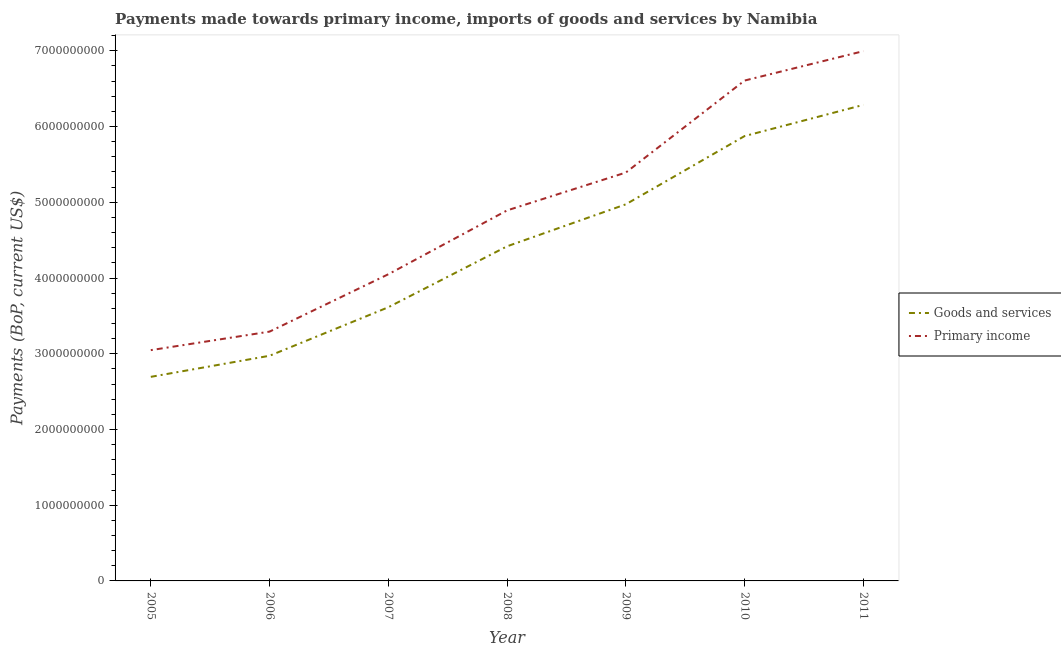How many different coloured lines are there?
Make the answer very short. 2. What is the payments made towards goods and services in 2006?
Give a very brief answer. 2.97e+09. Across all years, what is the maximum payments made towards primary income?
Provide a short and direct response. 7.00e+09. Across all years, what is the minimum payments made towards goods and services?
Make the answer very short. 2.69e+09. What is the total payments made towards primary income in the graph?
Provide a succinct answer. 3.43e+1. What is the difference between the payments made towards primary income in 2005 and that in 2010?
Your answer should be very brief. -3.56e+09. What is the difference between the payments made towards primary income in 2009 and the payments made towards goods and services in 2008?
Offer a terse response. 9.74e+08. What is the average payments made towards primary income per year?
Your answer should be very brief. 4.90e+09. In the year 2011, what is the difference between the payments made towards primary income and payments made towards goods and services?
Keep it short and to the point. 7.10e+08. What is the ratio of the payments made towards goods and services in 2007 to that in 2008?
Your answer should be very brief. 0.82. Is the payments made towards primary income in 2007 less than that in 2011?
Offer a terse response. Yes. Is the difference between the payments made towards goods and services in 2008 and 2009 greater than the difference between the payments made towards primary income in 2008 and 2009?
Your answer should be very brief. No. What is the difference between the highest and the second highest payments made towards primary income?
Offer a very short reply. 3.88e+08. What is the difference between the highest and the lowest payments made towards primary income?
Offer a terse response. 3.95e+09. Does the payments made towards primary income monotonically increase over the years?
Give a very brief answer. Yes. Is the payments made towards goods and services strictly less than the payments made towards primary income over the years?
Provide a succinct answer. Yes. How many years are there in the graph?
Your response must be concise. 7. What is the difference between two consecutive major ticks on the Y-axis?
Offer a very short reply. 1.00e+09. Are the values on the major ticks of Y-axis written in scientific E-notation?
Your answer should be very brief. No. Where does the legend appear in the graph?
Ensure brevity in your answer.  Center right. How are the legend labels stacked?
Your response must be concise. Vertical. What is the title of the graph?
Keep it short and to the point. Payments made towards primary income, imports of goods and services by Namibia. Does "IMF nonconcessional" appear as one of the legend labels in the graph?
Ensure brevity in your answer.  No. What is the label or title of the X-axis?
Offer a very short reply. Year. What is the label or title of the Y-axis?
Your answer should be compact. Payments (BoP, current US$). What is the Payments (BoP, current US$) in Goods and services in 2005?
Your response must be concise. 2.69e+09. What is the Payments (BoP, current US$) of Primary income in 2005?
Offer a terse response. 3.05e+09. What is the Payments (BoP, current US$) in Goods and services in 2006?
Keep it short and to the point. 2.97e+09. What is the Payments (BoP, current US$) of Primary income in 2006?
Offer a very short reply. 3.29e+09. What is the Payments (BoP, current US$) of Goods and services in 2007?
Give a very brief answer. 3.61e+09. What is the Payments (BoP, current US$) of Primary income in 2007?
Your answer should be very brief. 4.05e+09. What is the Payments (BoP, current US$) in Goods and services in 2008?
Your response must be concise. 4.42e+09. What is the Payments (BoP, current US$) in Primary income in 2008?
Your answer should be very brief. 4.89e+09. What is the Payments (BoP, current US$) of Goods and services in 2009?
Your answer should be very brief. 4.97e+09. What is the Payments (BoP, current US$) in Primary income in 2009?
Keep it short and to the point. 5.39e+09. What is the Payments (BoP, current US$) of Goods and services in 2010?
Make the answer very short. 5.87e+09. What is the Payments (BoP, current US$) of Primary income in 2010?
Offer a very short reply. 6.61e+09. What is the Payments (BoP, current US$) of Goods and services in 2011?
Keep it short and to the point. 6.29e+09. What is the Payments (BoP, current US$) of Primary income in 2011?
Provide a short and direct response. 7.00e+09. Across all years, what is the maximum Payments (BoP, current US$) of Goods and services?
Ensure brevity in your answer.  6.29e+09. Across all years, what is the maximum Payments (BoP, current US$) of Primary income?
Provide a short and direct response. 7.00e+09. Across all years, what is the minimum Payments (BoP, current US$) of Goods and services?
Your answer should be compact. 2.69e+09. Across all years, what is the minimum Payments (BoP, current US$) of Primary income?
Ensure brevity in your answer.  3.05e+09. What is the total Payments (BoP, current US$) of Goods and services in the graph?
Make the answer very short. 3.08e+1. What is the total Payments (BoP, current US$) in Primary income in the graph?
Provide a short and direct response. 3.43e+1. What is the difference between the Payments (BoP, current US$) of Goods and services in 2005 and that in 2006?
Offer a terse response. -2.78e+08. What is the difference between the Payments (BoP, current US$) of Primary income in 2005 and that in 2006?
Offer a very short reply. -2.45e+08. What is the difference between the Payments (BoP, current US$) in Goods and services in 2005 and that in 2007?
Ensure brevity in your answer.  -9.19e+08. What is the difference between the Payments (BoP, current US$) in Primary income in 2005 and that in 2007?
Offer a very short reply. -1.00e+09. What is the difference between the Payments (BoP, current US$) in Goods and services in 2005 and that in 2008?
Give a very brief answer. -1.72e+09. What is the difference between the Payments (BoP, current US$) in Primary income in 2005 and that in 2008?
Your response must be concise. -1.85e+09. What is the difference between the Payments (BoP, current US$) in Goods and services in 2005 and that in 2009?
Provide a succinct answer. -2.28e+09. What is the difference between the Payments (BoP, current US$) in Primary income in 2005 and that in 2009?
Your response must be concise. -2.35e+09. What is the difference between the Payments (BoP, current US$) in Goods and services in 2005 and that in 2010?
Offer a terse response. -3.18e+09. What is the difference between the Payments (BoP, current US$) of Primary income in 2005 and that in 2010?
Your answer should be very brief. -3.56e+09. What is the difference between the Payments (BoP, current US$) in Goods and services in 2005 and that in 2011?
Your answer should be compact. -3.59e+09. What is the difference between the Payments (BoP, current US$) of Primary income in 2005 and that in 2011?
Keep it short and to the point. -3.95e+09. What is the difference between the Payments (BoP, current US$) in Goods and services in 2006 and that in 2007?
Keep it short and to the point. -6.41e+08. What is the difference between the Payments (BoP, current US$) in Primary income in 2006 and that in 2007?
Your answer should be very brief. -7.57e+08. What is the difference between the Payments (BoP, current US$) in Goods and services in 2006 and that in 2008?
Ensure brevity in your answer.  -1.45e+09. What is the difference between the Payments (BoP, current US$) in Primary income in 2006 and that in 2008?
Ensure brevity in your answer.  -1.60e+09. What is the difference between the Payments (BoP, current US$) in Goods and services in 2006 and that in 2009?
Your answer should be very brief. -2.00e+09. What is the difference between the Payments (BoP, current US$) in Primary income in 2006 and that in 2009?
Provide a succinct answer. -2.10e+09. What is the difference between the Payments (BoP, current US$) of Goods and services in 2006 and that in 2010?
Offer a very short reply. -2.90e+09. What is the difference between the Payments (BoP, current US$) in Primary income in 2006 and that in 2010?
Your answer should be very brief. -3.32e+09. What is the difference between the Payments (BoP, current US$) in Goods and services in 2006 and that in 2011?
Make the answer very short. -3.31e+09. What is the difference between the Payments (BoP, current US$) of Primary income in 2006 and that in 2011?
Your answer should be compact. -3.70e+09. What is the difference between the Payments (BoP, current US$) in Goods and services in 2007 and that in 2008?
Give a very brief answer. -8.05e+08. What is the difference between the Payments (BoP, current US$) in Primary income in 2007 and that in 2008?
Your answer should be compact. -8.43e+08. What is the difference between the Payments (BoP, current US$) in Goods and services in 2007 and that in 2009?
Your answer should be very brief. -1.36e+09. What is the difference between the Payments (BoP, current US$) in Primary income in 2007 and that in 2009?
Keep it short and to the point. -1.34e+09. What is the difference between the Payments (BoP, current US$) in Goods and services in 2007 and that in 2010?
Your response must be concise. -2.26e+09. What is the difference between the Payments (BoP, current US$) of Primary income in 2007 and that in 2010?
Ensure brevity in your answer.  -2.56e+09. What is the difference between the Payments (BoP, current US$) in Goods and services in 2007 and that in 2011?
Your answer should be very brief. -2.67e+09. What is the difference between the Payments (BoP, current US$) of Primary income in 2007 and that in 2011?
Offer a terse response. -2.95e+09. What is the difference between the Payments (BoP, current US$) in Goods and services in 2008 and that in 2009?
Make the answer very short. -5.55e+08. What is the difference between the Payments (BoP, current US$) in Primary income in 2008 and that in 2009?
Make the answer very short. -5.00e+08. What is the difference between the Payments (BoP, current US$) of Goods and services in 2008 and that in 2010?
Your answer should be compact. -1.46e+09. What is the difference between the Payments (BoP, current US$) of Primary income in 2008 and that in 2010?
Ensure brevity in your answer.  -1.71e+09. What is the difference between the Payments (BoP, current US$) in Goods and services in 2008 and that in 2011?
Your answer should be compact. -1.87e+09. What is the difference between the Payments (BoP, current US$) of Primary income in 2008 and that in 2011?
Your answer should be compact. -2.10e+09. What is the difference between the Payments (BoP, current US$) in Goods and services in 2009 and that in 2010?
Your answer should be compact. -9.01e+08. What is the difference between the Payments (BoP, current US$) of Primary income in 2009 and that in 2010?
Provide a succinct answer. -1.21e+09. What is the difference between the Payments (BoP, current US$) of Goods and services in 2009 and that in 2011?
Your answer should be compact. -1.31e+09. What is the difference between the Payments (BoP, current US$) in Primary income in 2009 and that in 2011?
Your answer should be very brief. -1.60e+09. What is the difference between the Payments (BoP, current US$) in Goods and services in 2010 and that in 2011?
Offer a terse response. -4.12e+08. What is the difference between the Payments (BoP, current US$) in Primary income in 2010 and that in 2011?
Offer a very short reply. -3.88e+08. What is the difference between the Payments (BoP, current US$) of Goods and services in 2005 and the Payments (BoP, current US$) of Primary income in 2006?
Keep it short and to the point. -5.97e+08. What is the difference between the Payments (BoP, current US$) of Goods and services in 2005 and the Payments (BoP, current US$) of Primary income in 2007?
Your response must be concise. -1.35e+09. What is the difference between the Payments (BoP, current US$) of Goods and services in 2005 and the Payments (BoP, current US$) of Primary income in 2008?
Ensure brevity in your answer.  -2.20e+09. What is the difference between the Payments (BoP, current US$) in Goods and services in 2005 and the Payments (BoP, current US$) in Primary income in 2009?
Your response must be concise. -2.70e+09. What is the difference between the Payments (BoP, current US$) of Goods and services in 2005 and the Payments (BoP, current US$) of Primary income in 2010?
Your answer should be very brief. -3.91e+09. What is the difference between the Payments (BoP, current US$) in Goods and services in 2005 and the Payments (BoP, current US$) in Primary income in 2011?
Your response must be concise. -4.30e+09. What is the difference between the Payments (BoP, current US$) of Goods and services in 2006 and the Payments (BoP, current US$) of Primary income in 2007?
Offer a terse response. -1.08e+09. What is the difference between the Payments (BoP, current US$) in Goods and services in 2006 and the Payments (BoP, current US$) in Primary income in 2008?
Ensure brevity in your answer.  -1.92e+09. What is the difference between the Payments (BoP, current US$) of Goods and services in 2006 and the Payments (BoP, current US$) of Primary income in 2009?
Ensure brevity in your answer.  -2.42e+09. What is the difference between the Payments (BoP, current US$) of Goods and services in 2006 and the Payments (BoP, current US$) of Primary income in 2010?
Provide a succinct answer. -3.63e+09. What is the difference between the Payments (BoP, current US$) of Goods and services in 2006 and the Payments (BoP, current US$) of Primary income in 2011?
Give a very brief answer. -4.02e+09. What is the difference between the Payments (BoP, current US$) of Goods and services in 2007 and the Payments (BoP, current US$) of Primary income in 2008?
Your answer should be compact. -1.28e+09. What is the difference between the Payments (BoP, current US$) in Goods and services in 2007 and the Payments (BoP, current US$) in Primary income in 2009?
Offer a very short reply. -1.78e+09. What is the difference between the Payments (BoP, current US$) of Goods and services in 2007 and the Payments (BoP, current US$) of Primary income in 2010?
Give a very brief answer. -2.99e+09. What is the difference between the Payments (BoP, current US$) of Goods and services in 2007 and the Payments (BoP, current US$) of Primary income in 2011?
Your response must be concise. -3.38e+09. What is the difference between the Payments (BoP, current US$) in Goods and services in 2008 and the Payments (BoP, current US$) in Primary income in 2009?
Give a very brief answer. -9.74e+08. What is the difference between the Payments (BoP, current US$) of Goods and services in 2008 and the Payments (BoP, current US$) of Primary income in 2010?
Make the answer very short. -2.19e+09. What is the difference between the Payments (BoP, current US$) in Goods and services in 2008 and the Payments (BoP, current US$) in Primary income in 2011?
Keep it short and to the point. -2.58e+09. What is the difference between the Payments (BoP, current US$) in Goods and services in 2009 and the Payments (BoP, current US$) in Primary income in 2010?
Give a very brief answer. -1.63e+09. What is the difference between the Payments (BoP, current US$) of Goods and services in 2009 and the Payments (BoP, current US$) of Primary income in 2011?
Ensure brevity in your answer.  -2.02e+09. What is the difference between the Payments (BoP, current US$) of Goods and services in 2010 and the Payments (BoP, current US$) of Primary income in 2011?
Keep it short and to the point. -1.12e+09. What is the average Payments (BoP, current US$) of Goods and services per year?
Your response must be concise. 4.40e+09. What is the average Payments (BoP, current US$) of Primary income per year?
Provide a succinct answer. 4.90e+09. In the year 2005, what is the difference between the Payments (BoP, current US$) of Goods and services and Payments (BoP, current US$) of Primary income?
Offer a terse response. -3.53e+08. In the year 2006, what is the difference between the Payments (BoP, current US$) of Goods and services and Payments (BoP, current US$) of Primary income?
Provide a short and direct response. -3.19e+08. In the year 2007, what is the difference between the Payments (BoP, current US$) of Goods and services and Payments (BoP, current US$) of Primary income?
Ensure brevity in your answer.  -4.36e+08. In the year 2008, what is the difference between the Payments (BoP, current US$) in Goods and services and Payments (BoP, current US$) in Primary income?
Your answer should be very brief. -4.74e+08. In the year 2009, what is the difference between the Payments (BoP, current US$) in Goods and services and Payments (BoP, current US$) in Primary income?
Your response must be concise. -4.20e+08. In the year 2010, what is the difference between the Payments (BoP, current US$) of Goods and services and Payments (BoP, current US$) of Primary income?
Offer a terse response. -7.33e+08. In the year 2011, what is the difference between the Payments (BoP, current US$) in Goods and services and Payments (BoP, current US$) in Primary income?
Offer a very short reply. -7.10e+08. What is the ratio of the Payments (BoP, current US$) in Goods and services in 2005 to that in 2006?
Your response must be concise. 0.91. What is the ratio of the Payments (BoP, current US$) in Primary income in 2005 to that in 2006?
Your answer should be compact. 0.93. What is the ratio of the Payments (BoP, current US$) of Goods and services in 2005 to that in 2007?
Offer a very short reply. 0.75. What is the ratio of the Payments (BoP, current US$) in Primary income in 2005 to that in 2007?
Keep it short and to the point. 0.75. What is the ratio of the Payments (BoP, current US$) in Goods and services in 2005 to that in 2008?
Provide a succinct answer. 0.61. What is the ratio of the Payments (BoP, current US$) of Primary income in 2005 to that in 2008?
Offer a terse response. 0.62. What is the ratio of the Payments (BoP, current US$) of Goods and services in 2005 to that in 2009?
Make the answer very short. 0.54. What is the ratio of the Payments (BoP, current US$) of Primary income in 2005 to that in 2009?
Provide a succinct answer. 0.57. What is the ratio of the Payments (BoP, current US$) in Goods and services in 2005 to that in 2010?
Give a very brief answer. 0.46. What is the ratio of the Payments (BoP, current US$) of Primary income in 2005 to that in 2010?
Give a very brief answer. 0.46. What is the ratio of the Payments (BoP, current US$) in Goods and services in 2005 to that in 2011?
Ensure brevity in your answer.  0.43. What is the ratio of the Payments (BoP, current US$) in Primary income in 2005 to that in 2011?
Offer a terse response. 0.44. What is the ratio of the Payments (BoP, current US$) of Goods and services in 2006 to that in 2007?
Ensure brevity in your answer.  0.82. What is the ratio of the Payments (BoP, current US$) of Primary income in 2006 to that in 2007?
Give a very brief answer. 0.81. What is the ratio of the Payments (BoP, current US$) of Goods and services in 2006 to that in 2008?
Give a very brief answer. 0.67. What is the ratio of the Payments (BoP, current US$) of Primary income in 2006 to that in 2008?
Ensure brevity in your answer.  0.67. What is the ratio of the Payments (BoP, current US$) of Goods and services in 2006 to that in 2009?
Offer a very short reply. 0.6. What is the ratio of the Payments (BoP, current US$) of Primary income in 2006 to that in 2009?
Keep it short and to the point. 0.61. What is the ratio of the Payments (BoP, current US$) of Goods and services in 2006 to that in 2010?
Your answer should be very brief. 0.51. What is the ratio of the Payments (BoP, current US$) in Primary income in 2006 to that in 2010?
Your response must be concise. 0.5. What is the ratio of the Payments (BoP, current US$) in Goods and services in 2006 to that in 2011?
Offer a terse response. 0.47. What is the ratio of the Payments (BoP, current US$) of Primary income in 2006 to that in 2011?
Your response must be concise. 0.47. What is the ratio of the Payments (BoP, current US$) of Goods and services in 2007 to that in 2008?
Offer a terse response. 0.82. What is the ratio of the Payments (BoP, current US$) in Primary income in 2007 to that in 2008?
Provide a succinct answer. 0.83. What is the ratio of the Payments (BoP, current US$) in Goods and services in 2007 to that in 2009?
Your answer should be compact. 0.73. What is the ratio of the Payments (BoP, current US$) in Primary income in 2007 to that in 2009?
Ensure brevity in your answer.  0.75. What is the ratio of the Payments (BoP, current US$) of Goods and services in 2007 to that in 2010?
Offer a terse response. 0.62. What is the ratio of the Payments (BoP, current US$) of Primary income in 2007 to that in 2010?
Your answer should be compact. 0.61. What is the ratio of the Payments (BoP, current US$) in Goods and services in 2007 to that in 2011?
Provide a short and direct response. 0.57. What is the ratio of the Payments (BoP, current US$) in Primary income in 2007 to that in 2011?
Your response must be concise. 0.58. What is the ratio of the Payments (BoP, current US$) in Goods and services in 2008 to that in 2009?
Make the answer very short. 0.89. What is the ratio of the Payments (BoP, current US$) in Primary income in 2008 to that in 2009?
Keep it short and to the point. 0.91. What is the ratio of the Payments (BoP, current US$) of Goods and services in 2008 to that in 2010?
Offer a terse response. 0.75. What is the ratio of the Payments (BoP, current US$) of Primary income in 2008 to that in 2010?
Provide a short and direct response. 0.74. What is the ratio of the Payments (BoP, current US$) in Goods and services in 2008 to that in 2011?
Your answer should be very brief. 0.7. What is the ratio of the Payments (BoP, current US$) of Primary income in 2008 to that in 2011?
Offer a terse response. 0.7. What is the ratio of the Payments (BoP, current US$) in Goods and services in 2009 to that in 2010?
Make the answer very short. 0.85. What is the ratio of the Payments (BoP, current US$) in Primary income in 2009 to that in 2010?
Offer a terse response. 0.82. What is the ratio of the Payments (BoP, current US$) of Goods and services in 2009 to that in 2011?
Make the answer very short. 0.79. What is the ratio of the Payments (BoP, current US$) of Primary income in 2009 to that in 2011?
Offer a very short reply. 0.77. What is the ratio of the Payments (BoP, current US$) in Goods and services in 2010 to that in 2011?
Make the answer very short. 0.93. What is the ratio of the Payments (BoP, current US$) of Primary income in 2010 to that in 2011?
Offer a very short reply. 0.94. What is the difference between the highest and the second highest Payments (BoP, current US$) in Goods and services?
Give a very brief answer. 4.12e+08. What is the difference between the highest and the second highest Payments (BoP, current US$) of Primary income?
Offer a terse response. 3.88e+08. What is the difference between the highest and the lowest Payments (BoP, current US$) in Goods and services?
Keep it short and to the point. 3.59e+09. What is the difference between the highest and the lowest Payments (BoP, current US$) in Primary income?
Your response must be concise. 3.95e+09. 